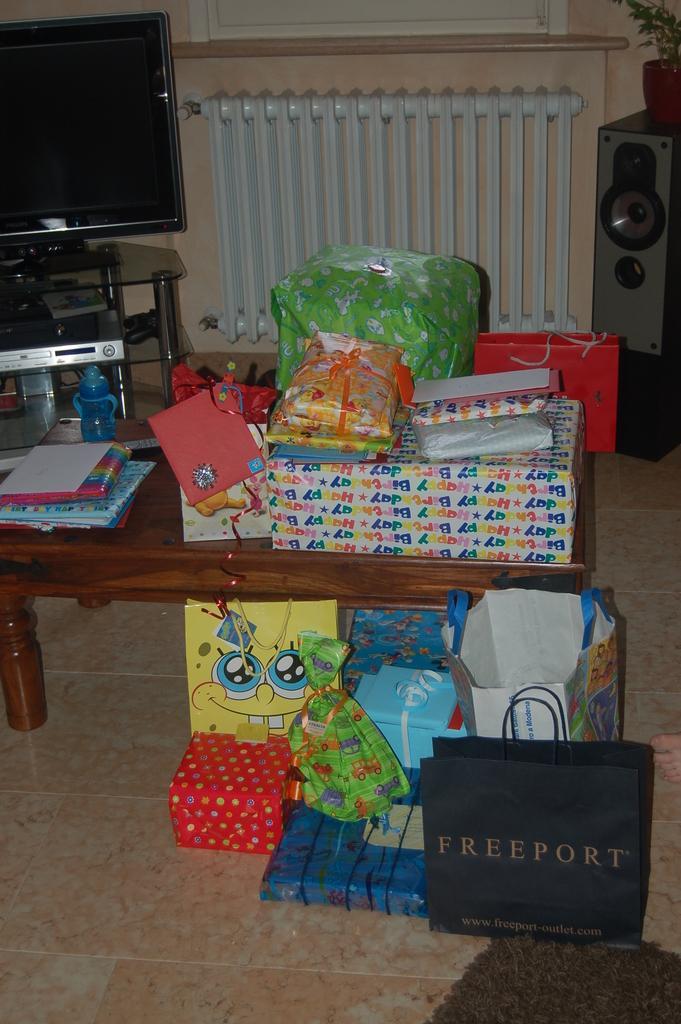Describe this image in one or two sentences. In this image we can see boxes, covers and books placed on the table. At the bottom of the image we can see boxes, cover and papers. In the background we can see speaker, player, television, water bottle and window. 